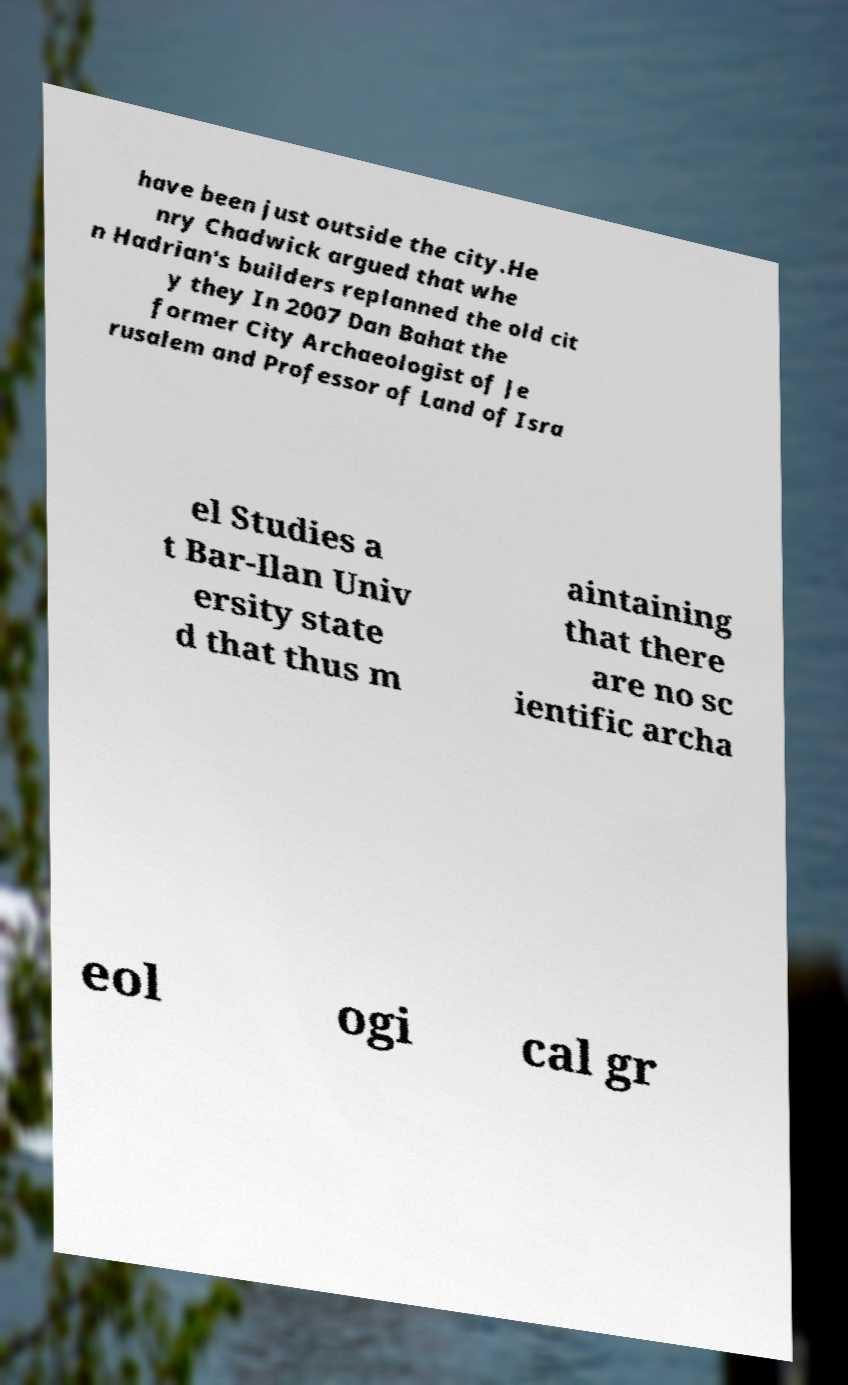Please identify and transcribe the text found in this image. have been just outside the city.He nry Chadwick argued that whe n Hadrian's builders replanned the old cit y they In 2007 Dan Bahat the former City Archaeologist of Je rusalem and Professor of Land of Isra el Studies a t Bar-Ilan Univ ersity state d that thus m aintaining that there are no sc ientific archa eol ogi cal gr 